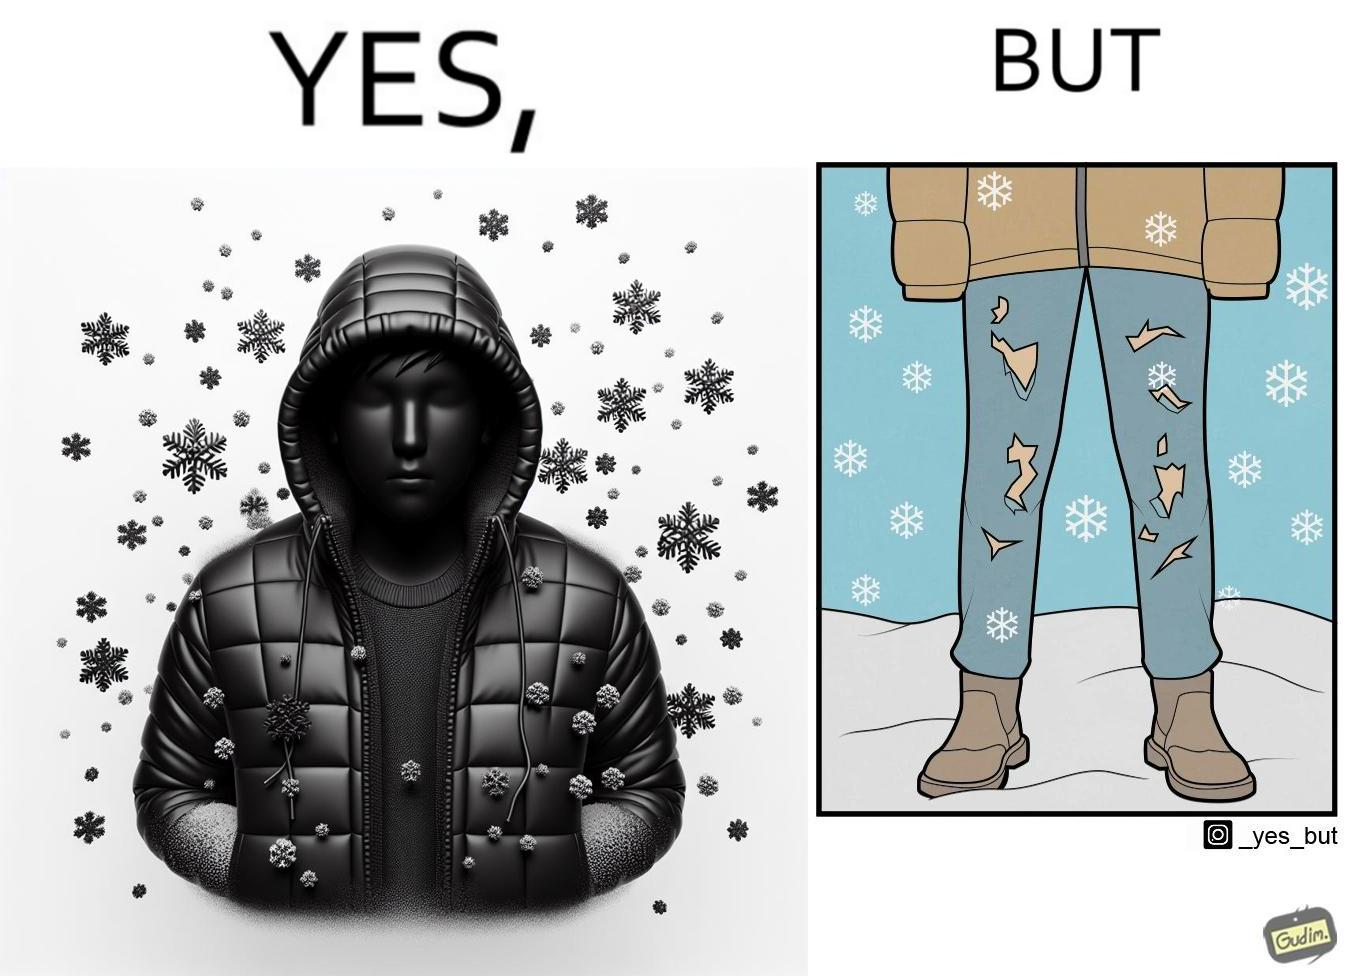Describe the contrast between the left and right parts of this image. In the left part of the image: A person wearing a yellow jacket, with snow falling around him. They look like they are feeling cold as their jacket is covering half their face. In the right part of the image: A person wearing torn up trousers, standing in an area with snowfall. They are also wearing boots and a jacket. 